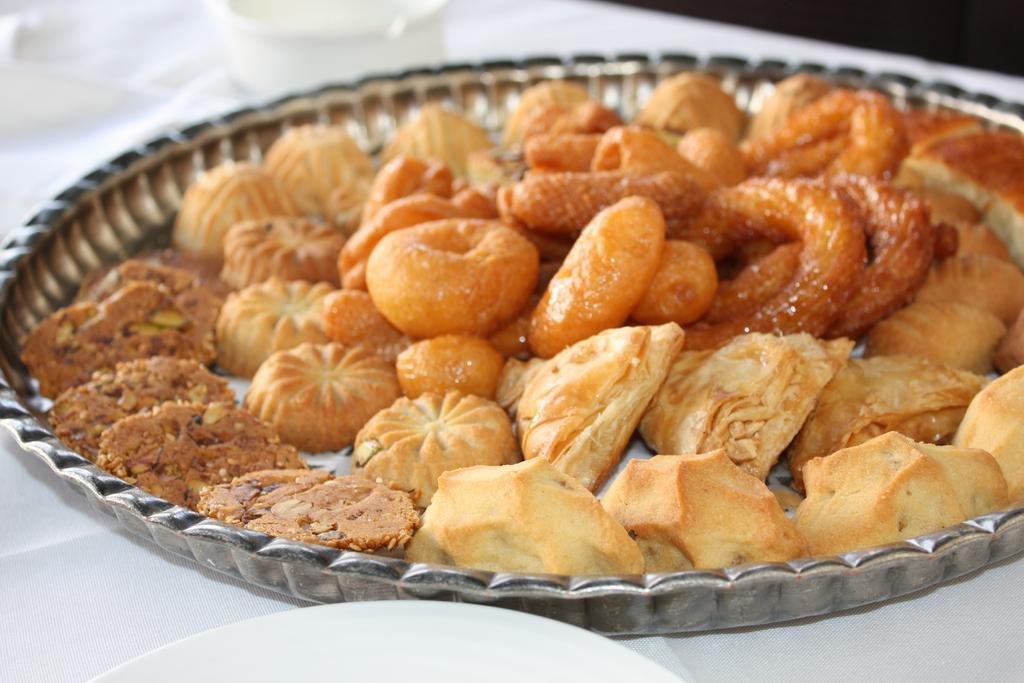How would you summarize this image in a sentence or two? In this image there is a food in the plate in the foreground. And there is an object in the background. We can see an object. There is white colored surface at the bottom. 